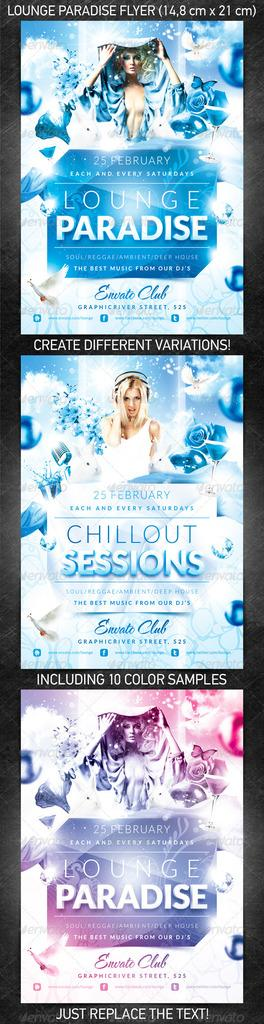<image>
Create a compact narrative representing the image presented. A flyer for Lounge Paradise has information about what will be happening there. 